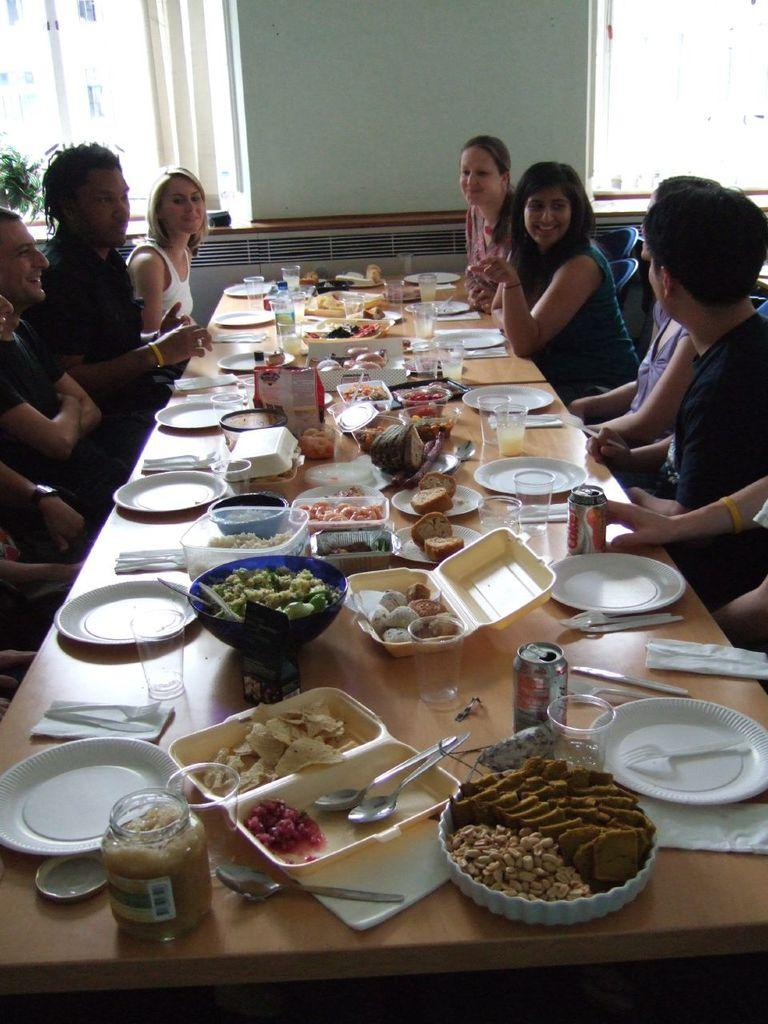What are the persons in the image doing? The persons in the image are sitting on chairs. What is located in front of the persons? There is a table in front of the persons. What can be seen on the table? There are plates and a bowl of food on the table. What type of weather can be seen in the image? The image does not depict any weather conditions; it shows persons sitting at a table with plates and a bowl of food. Can you describe the boot that is visible in the image? There is no boot present in the image. 